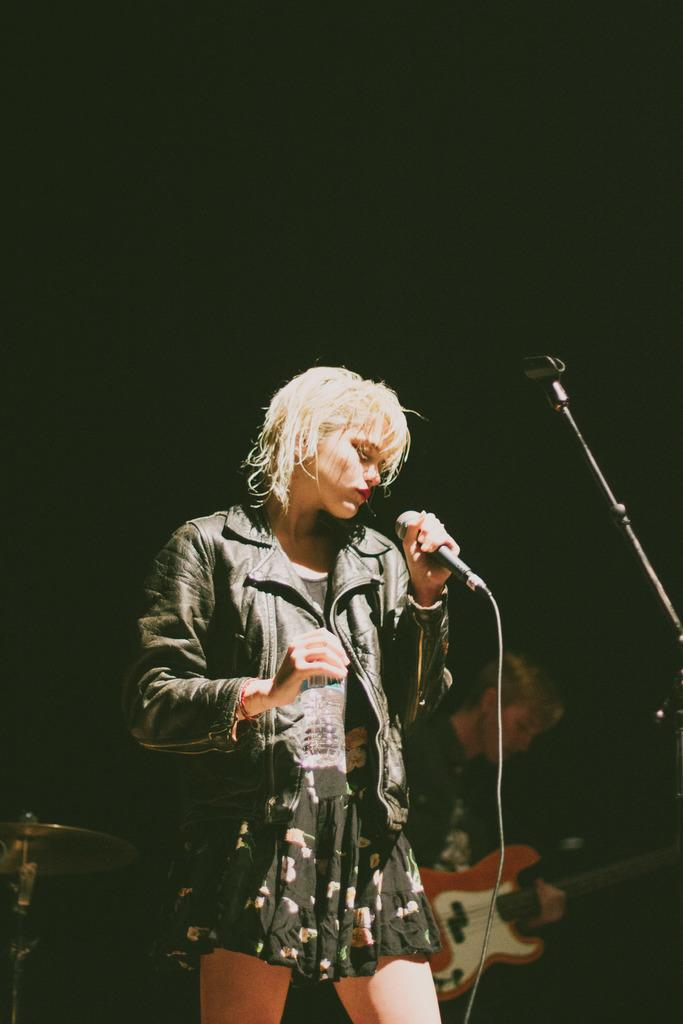What is the woman in the image holding? The woman is holding a microphone. What is the person in the image holding? The person is holding a guitar. Can you describe the activities of the individuals in the image? The woman appears to be singing or speaking into the microphone, while the person is playing the guitar. How many snails can be seen crawling on the guitar in the image? There are no snails visible in the image, and the guitar is not being crawled on by any snails. 